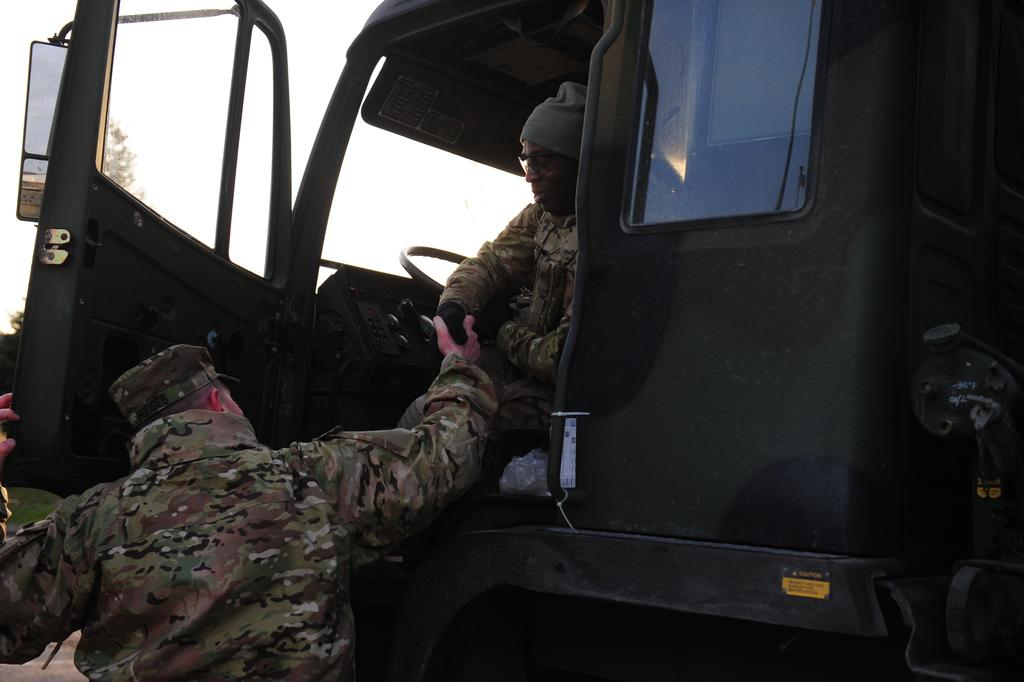What is the main object in the image? There is a vehicle in the image. Who is present in the image? There are two men in the image. What are the men wearing? Both men are wearing uniforms and caps. Can you describe one of the men's appearance in more detail? One of the men is wearing glasses (specs). What type of hearing aid is the man using in the image? There is no hearing aid visible in the image; the man is wearing glasses (specs). What activity are the men participating in while standing near the vehicle? The image does not provide information about any specific activity the men might be engaged in. 